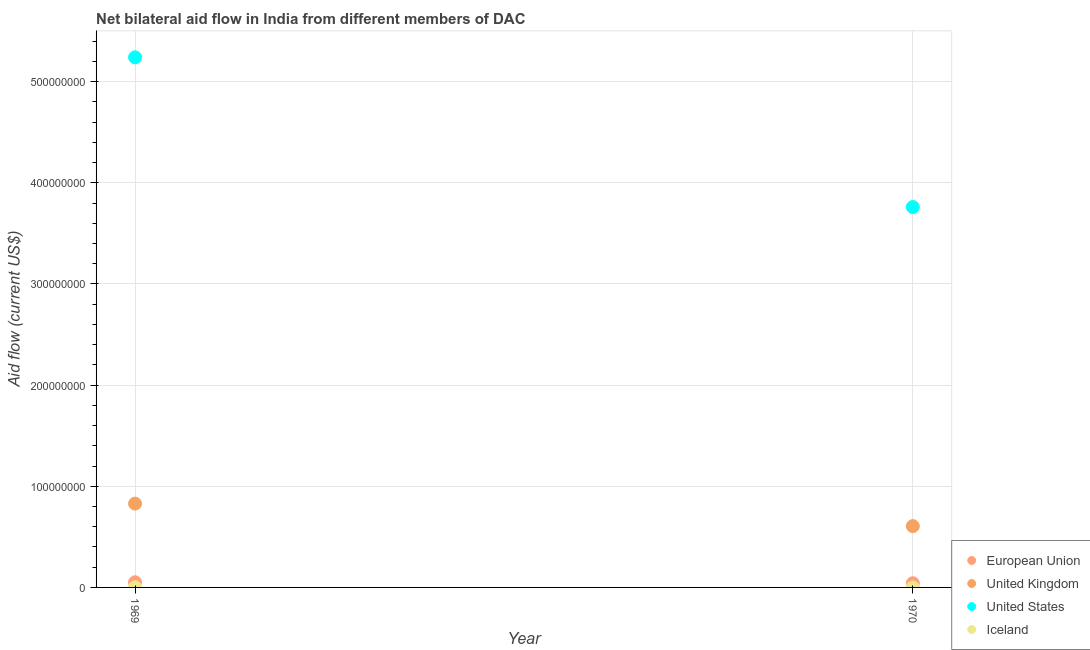How many different coloured dotlines are there?
Your response must be concise. 4. Is the number of dotlines equal to the number of legend labels?
Offer a terse response. Yes. What is the amount of aid given by eu in 1970?
Your answer should be compact. 4.15e+06. Across all years, what is the maximum amount of aid given by us?
Offer a very short reply. 5.24e+08. Across all years, what is the minimum amount of aid given by iceland?
Offer a terse response. 2.00e+04. In which year was the amount of aid given by eu maximum?
Offer a terse response. 1969. What is the total amount of aid given by iceland in the graph?
Your answer should be compact. 2.00e+05. What is the difference between the amount of aid given by uk in 1969 and that in 1970?
Your answer should be compact. 2.22e+07. What is the difference between the amount of aid given by uk in 1969 and the amount of aid given by iceland in 1970?
Your answer should be very brief. 8.28e+07. What is the average amount of aid given by iceland per year?
Provide a succinct answer. 1.00e+05. In the year 1969, what is the difference between the amount of aid given by iceland and amount of aid given by eu?
Your answer should be compact. -4.91e+06. What is the ratio of the amount of aid given by eu in 1969 to that in 1970?
Provide a succinct answer. 1.23. In how many years, is the amount of aid given by us greater than the average amount of aid given by us taken over all years?
Keep it short and to the point. 1. Is it the case that in every year, the sum of the amount of aid given by eu and amount of aid given by us is greater than the sum of amount of aid given by iceland and amount of aid given by uk?
Your answer should be compact. Yes. Is it the case that in every year, the sum of the amount of aid given by eu and amount of aid given by uk is greater than the amount of aid given by us?
Give a very brief answer. No. Is the amount of aid given by iceland strictly less than the amount of aid given by us over the years?
Offer a terse response. Yes. What is the difference between two consecutive major ticks on the Y-axis?
Make the answer very short. 1.00e+08. Are the values on the major ticks of Y-axis written in scientific E-notation?
Keep it short and to the point. No. Where does the legend appear in the graph?
Your answer should be compact. Bottom right. How many legend labels are there?
Offer a terse response. 4. What is the title of the graph?
Keep it short and to the point. Net bilateral aid flow in India from different members of DAC. What is the label or title of the Y-axis?
Your answer should be very brief. Aid flow (current US$). What is the Aid flow (current US$) in European Union in 1969?
Ensure brevity in your answer.  5.09e+06. What is the Aid flow (current US$) in United Kingdom in 1969?
Provide a succinct answer. 8.28e+07. What is the Aid flow (current US$) in United States in 1969?
Give a very brief answer. 5.24e+08. What is the Aid flow (current US$) in Iceland in 1969?
Provide a short and direct response. 1.80e+05. What is the Aid flow (current US$) of European Union in 1970?
Provide a succinct answer. 4.15e+06. What is the Aid flow (current US$) in United Kingdom in 1970?
Offer a terse response. 6.06e+07. What is the Aid flow (current US$) in United States in 1970?
Offer a terse response. 3.76e+08. Across all years, what is the maximum Aid flow (current US$) of European Union?
Offer a very short reply. 5.09e+06. Across all years, what is the maximum Aid flow (current US$) of United Kingdom?
Keep it short and to the point. 8.28e+07. Across all years, what is the maximum Aid flow (current US$) in United States?
Ensure brevity in your answer.  5.24e+08. Across all years, what is the maximum Aid flow (current US$) of Iceland?
Provide a short and direct response. 1.80e+05. Across all years, what is the minimum Aid flow (current US$) of European Union?
Make the answer very short. 4.15e+06. Across all years, what is the minimum Aid flow (current US$) in United Kingdom?
Offer a terse response. 6.06e+07. Across all years, what is the minimum Aid flow (current US$) in United States?
Give a very brief answer. 3.76e+08. What is the total Aid flow (current US$) of European Union in the graph?
Provide a short and direct response. 9.24e+06. What is the total Aid flow (current US$) of United Kingdom in the graph?
Your answer should be compact. 1.43e+08. What is the total Aid flow (current US$) in United States in the graph?
Your response must be concise. 9.00e+08. What is the total Aid flow (current US$) of Iceland in the graph?
Keep it short and to the point. 2.00e+05. What is the difference between the Aid flow (current US$) of European Union in 1969 and that in 1970?
Make the answer very short. 9.40e+05. What is the difference between the Aid flow (current US$) in United Kingdom in 1969 and that in 1970?
Keep it short and to the point. 2.22e+07. What is the difference between the Aid flow (current US$) of United States in 1969 and that in 1970?
Ensure brevity in your answer.  1.48e+08. What is the difference between the Aid flow (current US$) in European Union in 1969 and the Aid flow (current US$) in United Kingdom in 1970?
Offer a very short reply. -5.55e+07. What is the difference between the Aid flow (current US$) in European Union in 1969 and the Aid flow (current US$) in United States in 1970?
Give a very brief answer. -3.71e+08. What is the difference between the Aid flow (current US$) in European Union in 1969 and the Aid flow (current US$) in Iceland in 1970?
Your answer should be very brief. 5.07e+06. What is the difference between the Aid flow (current US$) of United Kingdom in 1969 and the Aid flow (current US$) of United States in 1970?
Make the answer very short. -2.93e+08. What is the difference between the Aid flow (current US$) of United Kingdom in 1969 and the Aid flow (current US$) of Iceland in 1970?
Your answer should be very brief. 8.28e+07. What is the difference between the Aid flow (current US$) in United States in 1969 and the Aid flow (current US$) in Iceland in 1970?
Provide a succinct answer. 5.24e+08. What is the average Aid flow (current US$) in European Union per year?
Offer a very short reply. 4.62e+06. What is the average Aid flow (current US$) in United Kingdom per year?
Make the answer very short. 7.17e+07. What is the average Aid flow (current US$) in United States per year?
Offer a terse response. 4.50e+08. What is the average Aid flow (current US$) in Iceland per year?
Make the answer very short. 1.00e+05. In the year 1969, what is the difference between the Aid flow (current US$) in European Union and Aid flow (current US$) in United Kingdom?
Ensure brevity in your answer.  -7.78e+07. In the year 1969, what is the difference between the Aid flow (current US$) in European Union and Aid flow (current US$) in United States?
Ensure brevity in your answer.  -5.19e+08. In the year 1969, what is the difference between the Aid flow (current US$) in European Union and Aid flow (current US$) in Iceland?
Offer a terse response. 4.91e+06. In the year 1969, what is the difference between the Aid flow (current US$) of United Kingdom and Aid flow (current US$) of United States?
Ensure brevity in your answer.  -4.41e+08. In the year 1969, what is the difference between the Aid flow (current US$) in United Kingdom and Aid flow (current US$) in Iceland?
Give a very brief answer. 8.27e+07. In the year 1969, what is the difference between the Aid flow (current US$) in United States and Aid flow (current US$) in Iceland?
Provide a short and direct response. 5.24e+08. In the year 1970, what is the difference between the Aid flow (current US$) in European Union and Aid flow (current US$) in United Kingdom?
Give a very brief answer. -5.64e+07. In the year 1970, what is the difference between the Aid flow (current US$) in European Union and Aid flow (current US$) in United States?
Keep it short and to the point. -3.72e+08. In the year 1970, what is the difference between the Aid flow (current US$) in European Union and Aid flow (current US$) in Iceland?
Your answer should be compact. 4.13e+06. In the year 1970, what is the difference between the Aid flow (current US$) of United Kingdom and Aid flow (current US$) of United States?
Provide a succinct answer. -3.15e+08. In the year 1970, what is the difference between the Aid flow (current US$) in United Kingdom and Aid flow (current US$) in Iceland?
Provide a succinct answer. 6.06e+07. In the year 1970, what is the difference between the Aid flow (current US$) in United States and Aid flow (current US$) in Iceland?
Give a very brief answer. 3.76e+08. What is the ratio of the Aid flow (current US$) in European Union in 1969 to that in 1970?
Keep it short and to the point. 1.23. What is the ratio of the Aid flow (current US$) in United Kingdom in 1969 to that in 1970?
Ensure brevity in your answer.  1.37. What is the ratio of the Aid flow (current US$) in United States in 1969 to that in 1970?
Keep it short and to the point. 1.39. What is the difference between the highest and the second highest Aid flow (current US$) of European Union?
Your answer should be compact. 9.40e+05. What is the difference between the highest and the second highest Aid flow (current US$) in United Kingdom?
Make the answer very short. 2.22e+07. What is the difference between the highest and the second highest Aid flow (current US$) of United States?
Give a very brief answer. 1.48e+08. What is the difference between the highest and the lowest Aid flow (current US$) in European Union?
Your answer should be very brief. 9.40e+05. What is the difference between the highest and the lowest Aid flow (current US$) in United Kingdom?
Keep it short and to the point. 2.22e+07. What is the difference between the highest and the lowest Aid flow (current US$) of United States?
Provide a short and direct response. 1.48e+08. What is the difference between the highest and the lowest Aid flow (current US$) in Iceland?
Ensure brevity in your answer.  1.60e+05. 